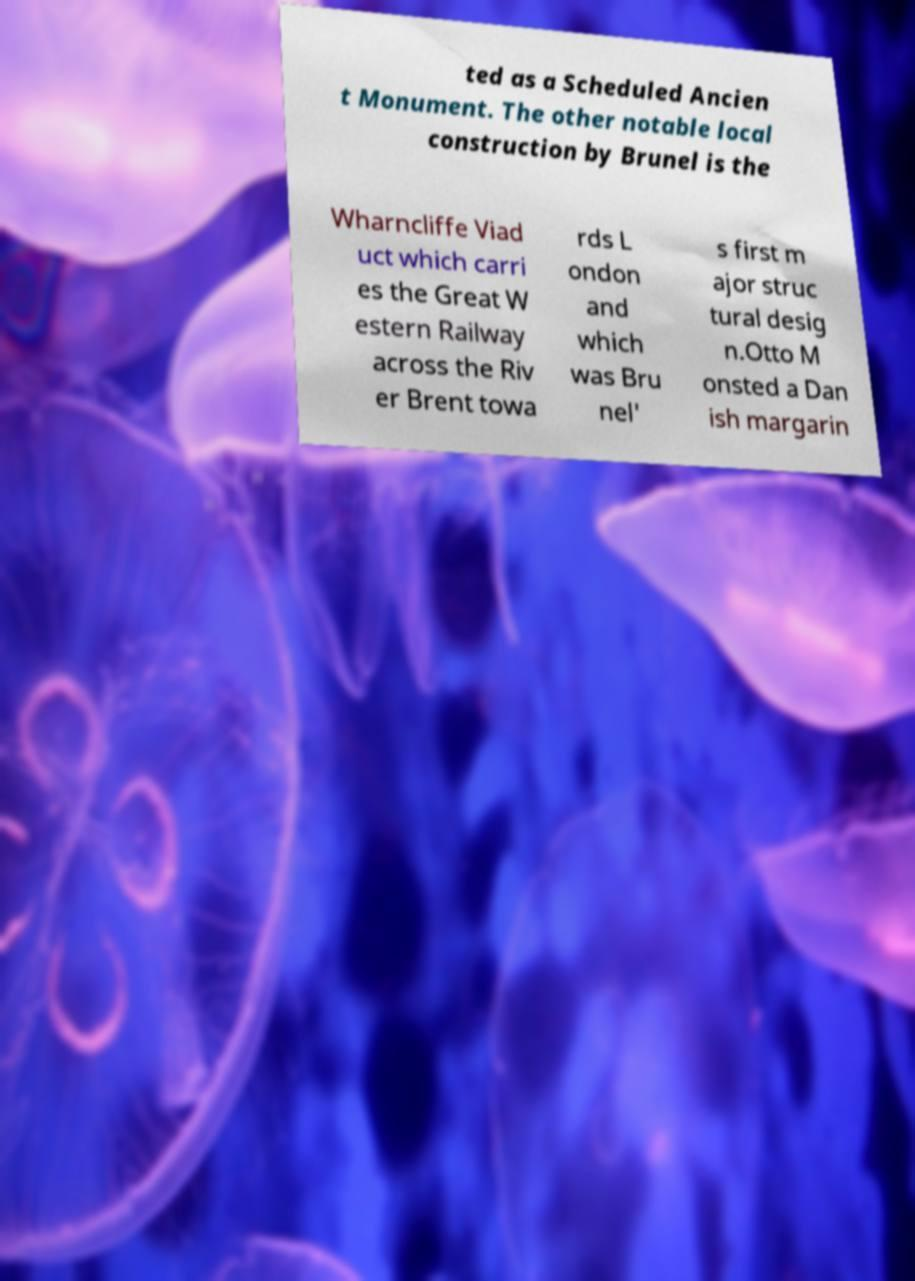Please identify and transcribe the text found in this image. ted as a Scheduled Ancien t Monument. The other notable local construction by Brunel is the Wharncliffe Viad uct which carri es the Great W estern Railway across the Riv er Brent towa rds L ondon and which was Bru nel' s first m ajor struc tural desig n.Otto M onsted a Dan ish margarin 